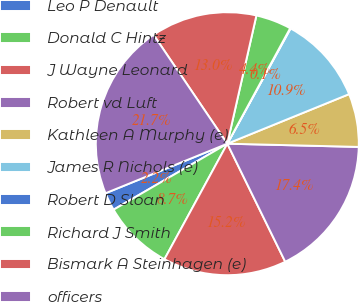Convert chart. <chart><loc_0><loc_0><loc_500><loc_500><pie_chart><fcel>Leo P Denault<fcel>Donald C Hintz<fcel>J Wayne Leonard<fcel>Robert vd Luft<fcel>Kathleen A Murphy (e)<fcel>James R Nichols (e)<fcel>Robert D Sloan<fcel>Richard J Smith<fcel>Bismark A Steinhagen (e)<fcel>officers<nl><fcel>2.22%<fcel>8.7%<fcel>15.19%<fcel>17.35%<fcel>6.54%<fcel>10.86%<fcel>0.06%<fcel>4.38%<fcel>13.03%<fcel>21.67%<nl></chart> 